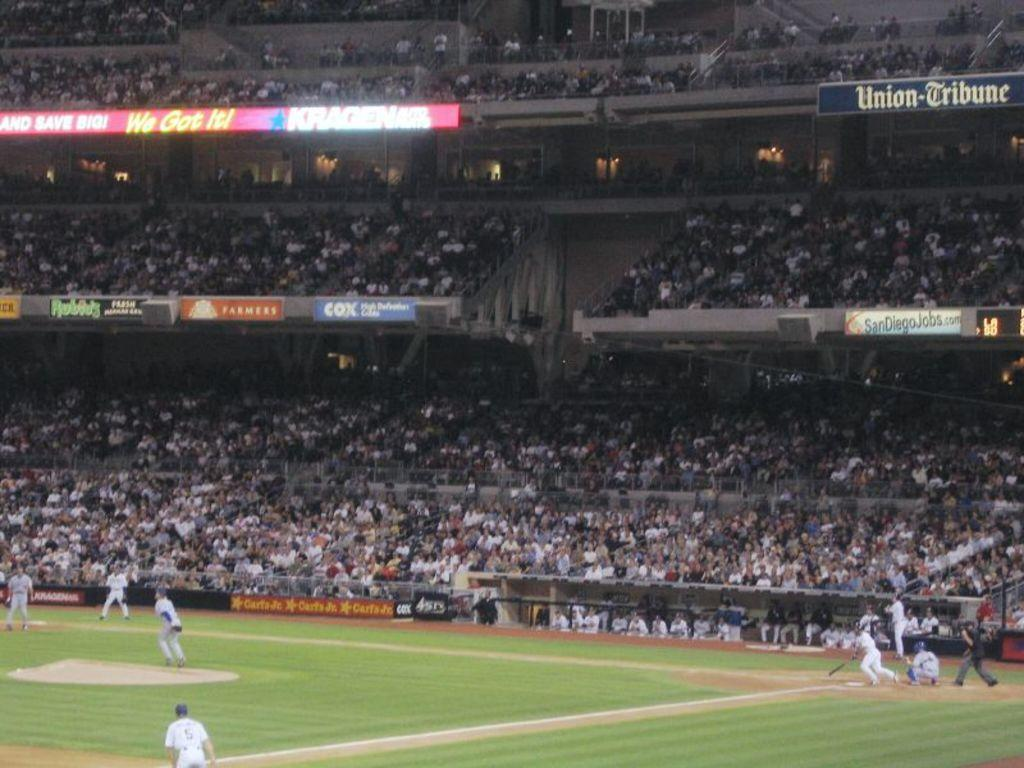Provide a one-sentence caption for the provided image. A baseball stadium with several banners advertising companies including COX. 